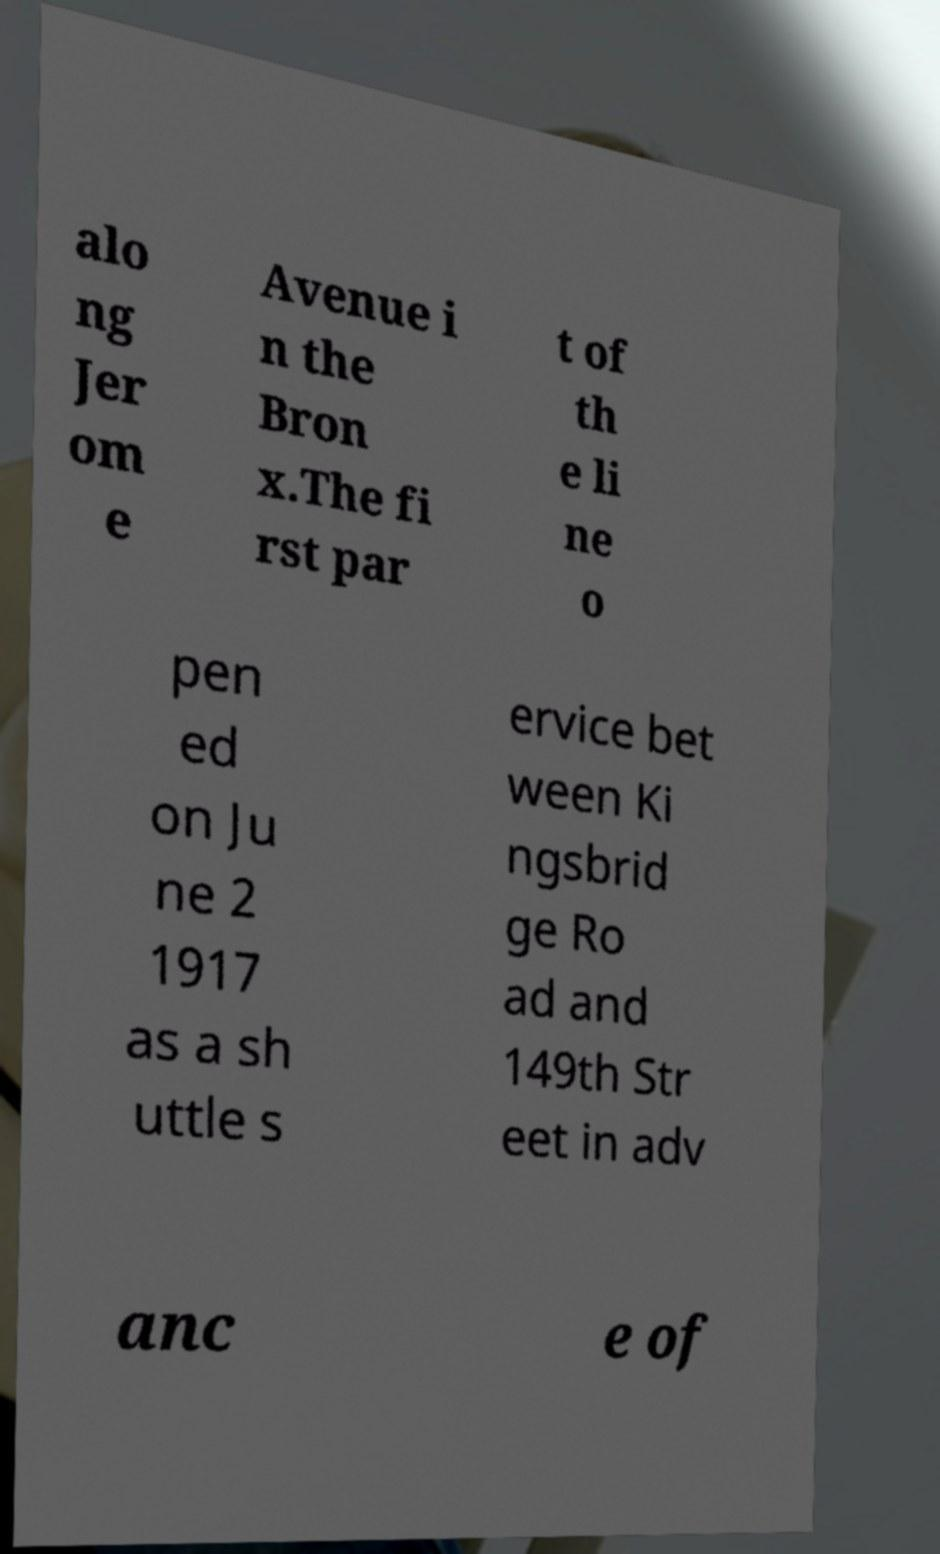I need the written content from this picture converted into text. Can you do that? alo ng Jer om e Avenue i n the Bron x.The fi rst par t of th e li ne o pen ed on Ju ne 2 1917 as a sh uttle s ervice bet ween Ki ngsbrid ge Ro ad and 149th Str eet in adv anc e of 